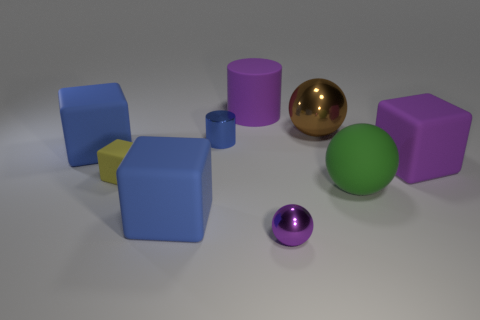Add 1 big green balls. How many objects exist? 10 Subtract all cylinders. How many objects are left? 7 Subtract all tiny blue blocks. Subtract all tiny spheres. How many objects are left? 8 Add 7 purple metallic spheres. How many purple metallic spheres are left? 8 Add 8 small red shiny objects. How many small red shiny objects exist? 8 Subtract 0 gray spheres. How many objects are left? 9 